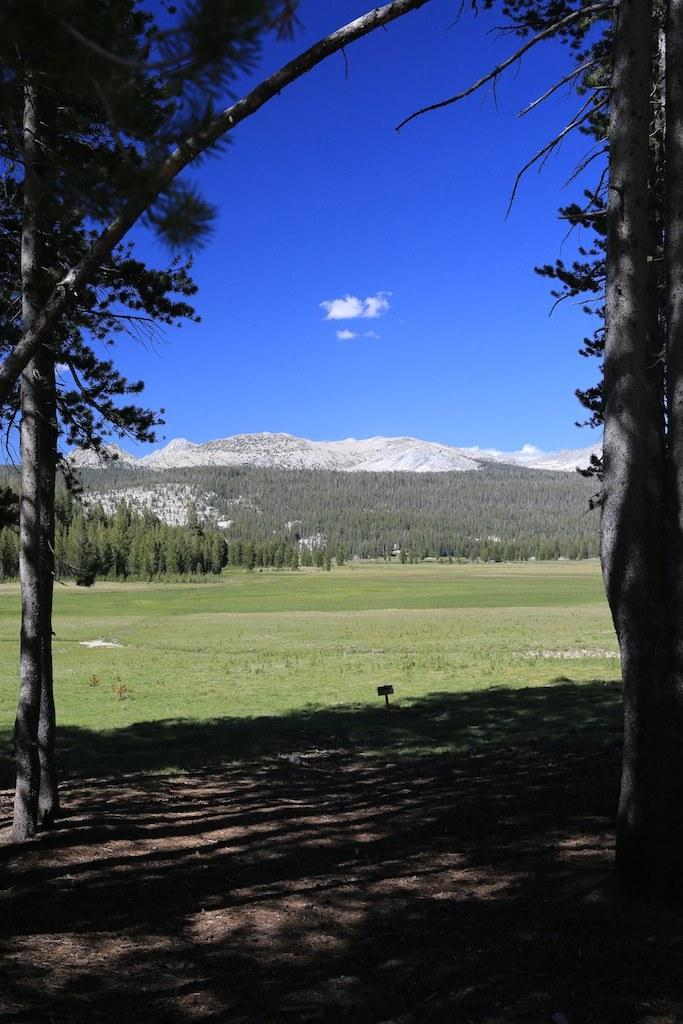What type of ground is visible in the image? There is a ground covered with grass in the image. What can be seen growing in the image? There are trees visible in the image. What type of landscape feature is present in the image? There are mountains in the image. What type of twig can be seen in the image? There is no twig present in the image. What kind of apparatus is being used by the mountains in the image? The mountains are not using any apparatus in the image; they are a natural landscape feature. 